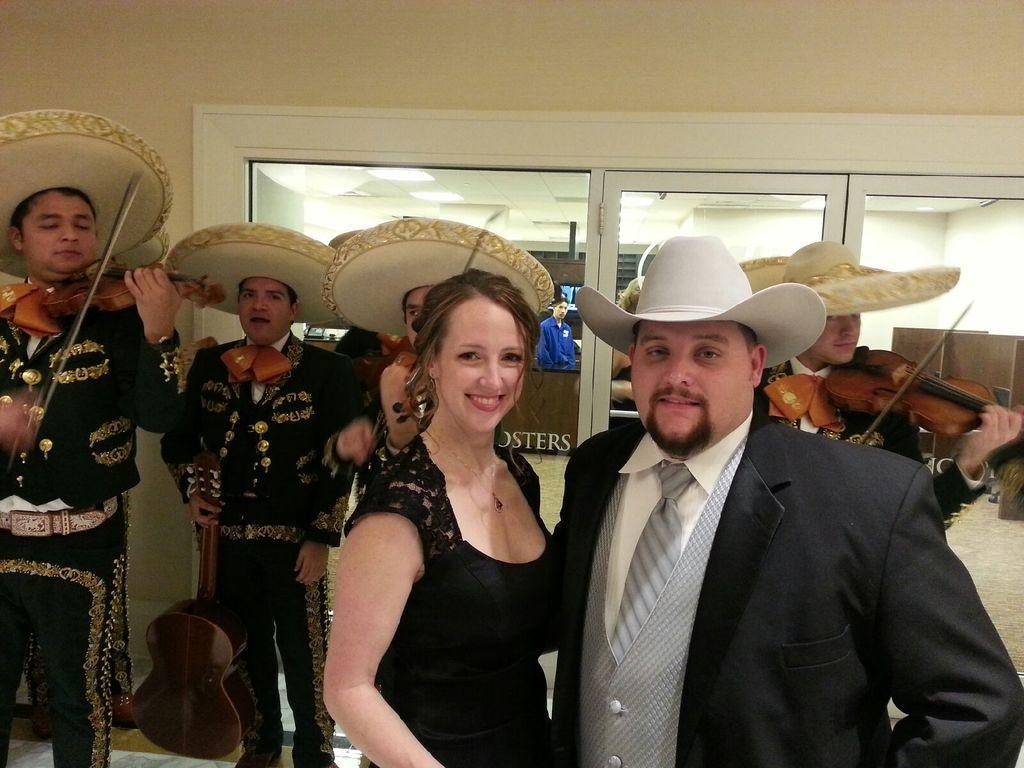Please provide a concise description of this image. In this image we can see a woman wearing black dress and man wearing blazer are standing. In the background we can see people wearing uniform are holding violin in their hands and playing it. 